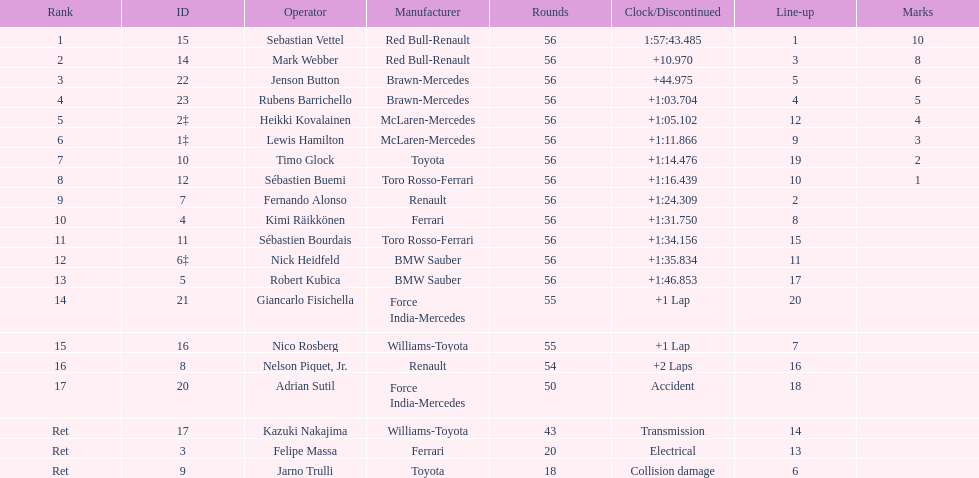What is the count of drivers who did not manage to complete 56 laps? 7. 